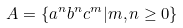<formula> <loc_0><loc_0><loc_500><loc_500>A = \{ a ^ { n } b ^ { n } c ^ { m } | m , n \geq 0 \}</formula> 